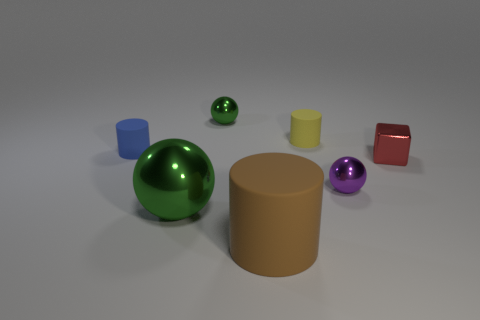Subtract all gray spheres. Subtract all cyan cylinders. How many spheres are left? 3 Add 3 yellow things. How many objects exist? 10 Subtract all cylinders. How many objects are left? 4 Add 6 tiny yellow objects. How many tiny yellow objects exist? 7 Subtract 0 gray cylinders. How many objects are left? 7 Subtract all large green shiny objects. Subtract all small red cubes. How many objects are left? 5 Add 3 small green metallic objects. How many small green metallic objects are left? 4 